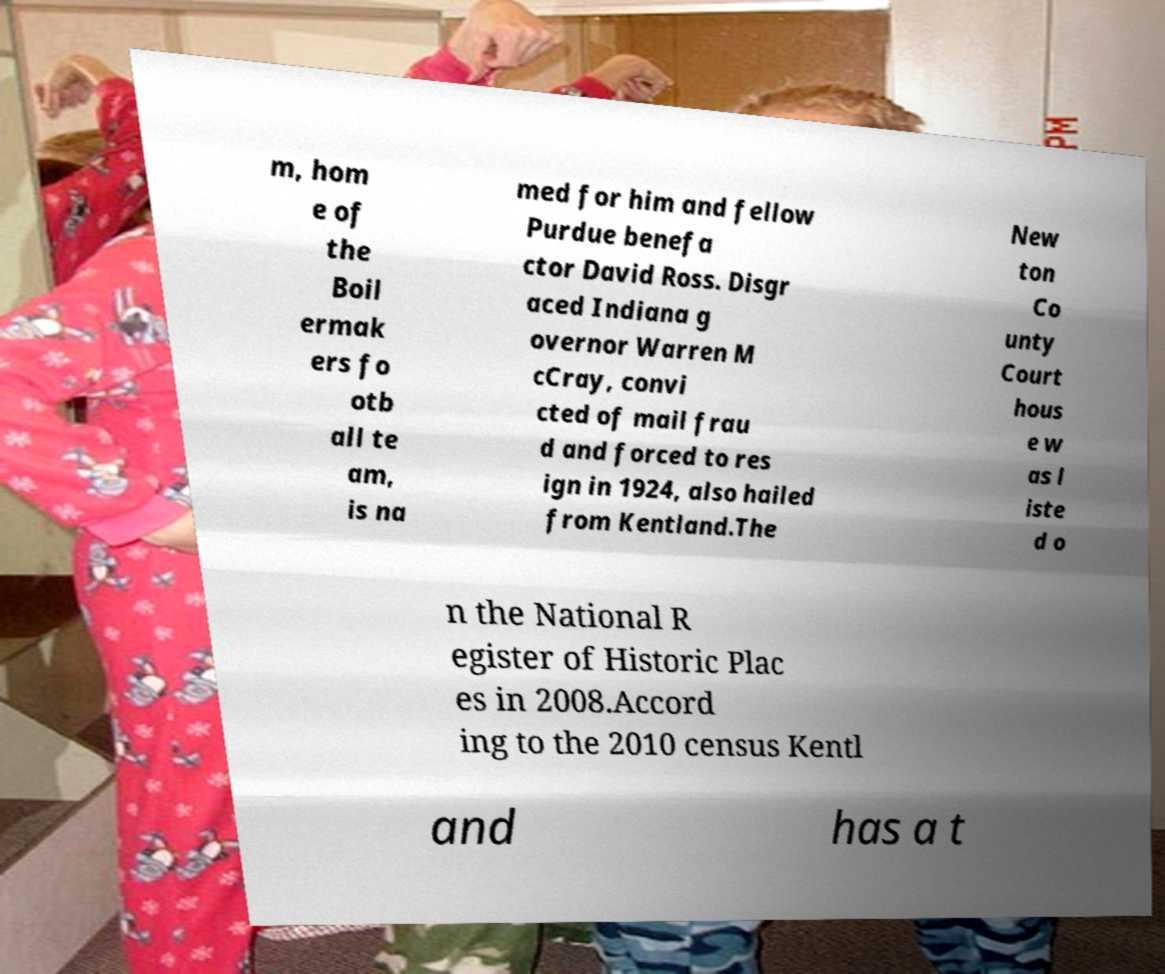I need the written content from this picture converted into text. Can you do that? m, hom e of the Boil ermak ers fo otb all te am, is na med for him and fellow Purdue benefa ctor David Ross. Disgr aced Indiana g overnor Warren M cCray, convi cted of mail frau d and forced to res ign in 1924, also hailed from Kentland.The New ton Co unty Court hous e w as l iste d o n the National R egister of Historic Plac es in 2008.Accord ing to the 2010 census Kentl and has a t 